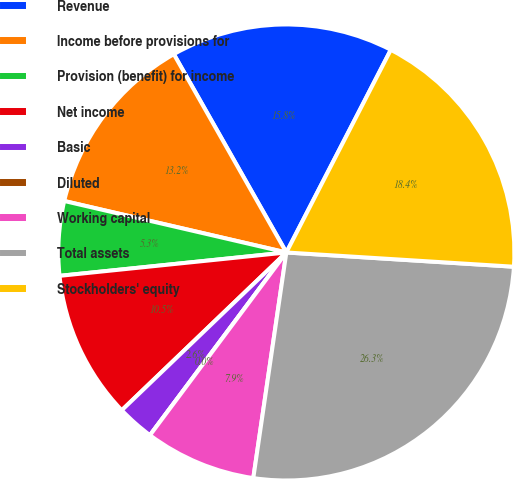<chart> <loc_0><loc_0><loc_500><loc_500><pie_chart><fcel>Revenue<fcel>Income before provisions for<fcel>Provision (benefit) for income<fcel>Net income<fcel>Basic<fcel>Diluted<fcel>Working capital<fcel>Total assets<fcel>Stockholders' equity<nl><fcel>15.79%<fcel>13.16%<fcel>5.26%<fcel>10.53%<fcel>2.63%<fcel>0.0%<fcel>7.89%<fcel>26.32%<fcel>18.42%<nl></chart> 